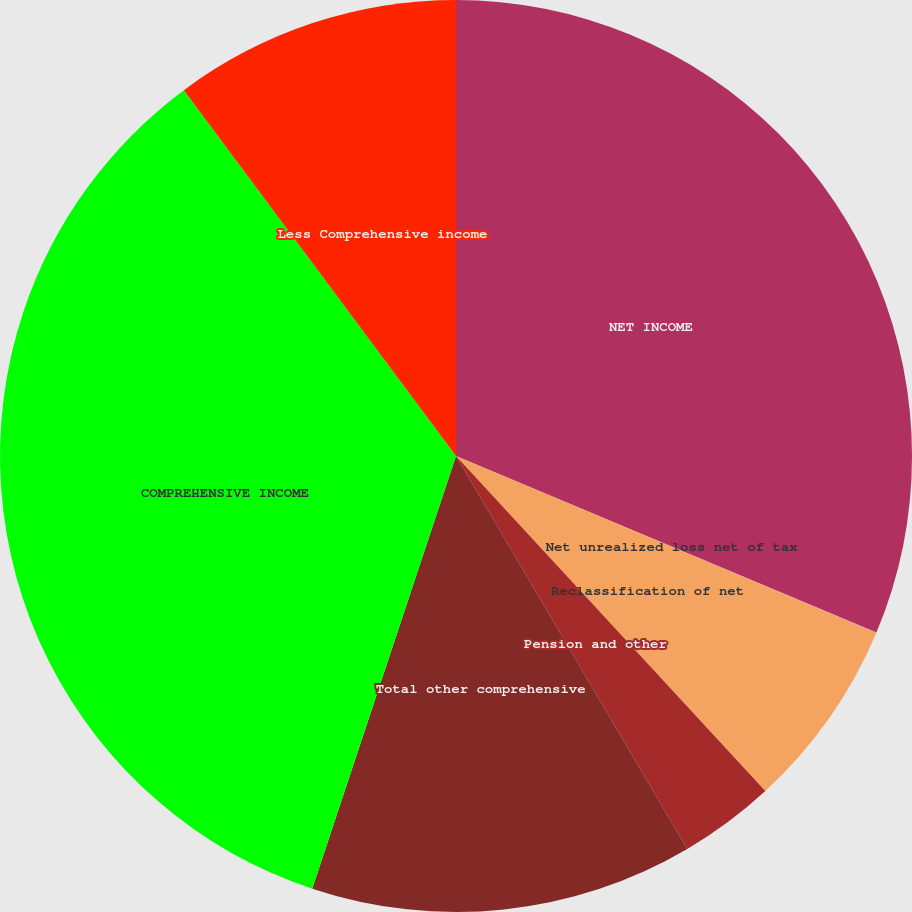Convert chart. <chart><loc_0><loc_0><loc_500><loc_500><pie_chart><fcel>NET INCOME<fcel>Net unrealized loss net of tax<fcel>Reclassification of net<fcel>Pension and other<fcel>Total other comprehensive<fcel>COMPREHENSIVE INCOME<fcel>Less Comprehensive income<nl><fcel>31.33%<fcel>0.02%<fcel>6.79%<fcel>3.4%<fcel>13.57%<fcel>34.72%<fcel>10.18%<nl></chart> 